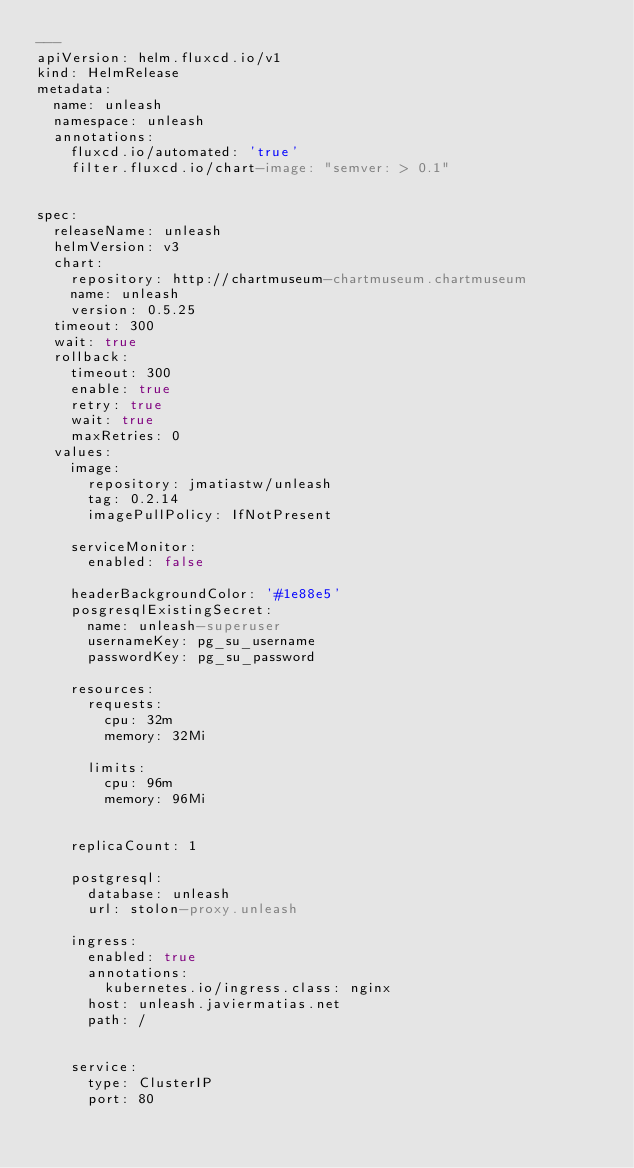Convert code to text. <code><loc_0><loc_0><loc_500><loc_500><_YAML_>---
apiVersion: helm.fluxcd.io/v1
kind: HelmRelease
metadata:
  name: unleash
  namespace: unleash
  annotations:
    fluxcd.io/automated: 'true'
    filter.fluxcd.io/chart-image: "semver: > 0.1"


spec:
  releaseName: unleash
  helmVersion: v3
  chart:
    repository: http://chartmuseum-chartmuseum.chartmuseum
    name: unleash
    version: 0.5.25
  timeout: 300
  wait: true
  rollback:
    timeout: 300
    enable: true
    retry: true
    wait: true
    maxRetries: 0
  values:
    image:
      repository: jmatiastw/unleash
      tag: 0.2.14
      imagePullPolicy: IfNotPresent

    serviceMonitor:
      enabled: false

    headerBackgroundColor: '#1e88e5'
    posgresqlExistingSecret:
      name: unleash-superuser
      usernameKey: pg_su_username
      passwordKey: pg_su_password

    resources:
      requests:
        cpu: 32m
        memory: 32Mi

      limits:
        cpu: 96m
        memory: 96Mi


    replicaCount: 1

    postgresql:
      database: unleash
      url: stolon-proxy.unleash

    ingress:
      enabled: true
      annotations:
        kubernetes.io/ingress.class: nginx
      host: unleash.javiermatias.net
      path: /


    service:
      type: ClusterIP
      port: 80

</code> 